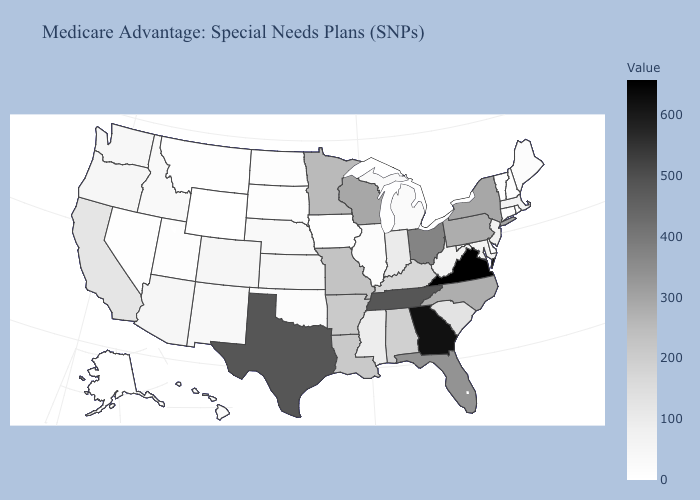Which states have the lowest value in the West?
Be succinct. Alaska, Wyoming. Does New York have the lowest value in the USA?
Answer briefly. No. Among the states that border Missouri , does Oklahoma have the lowest value?
Answer briefly. No. Does New York have the highest value in the Northeast?
Keep it brief. Yes. 